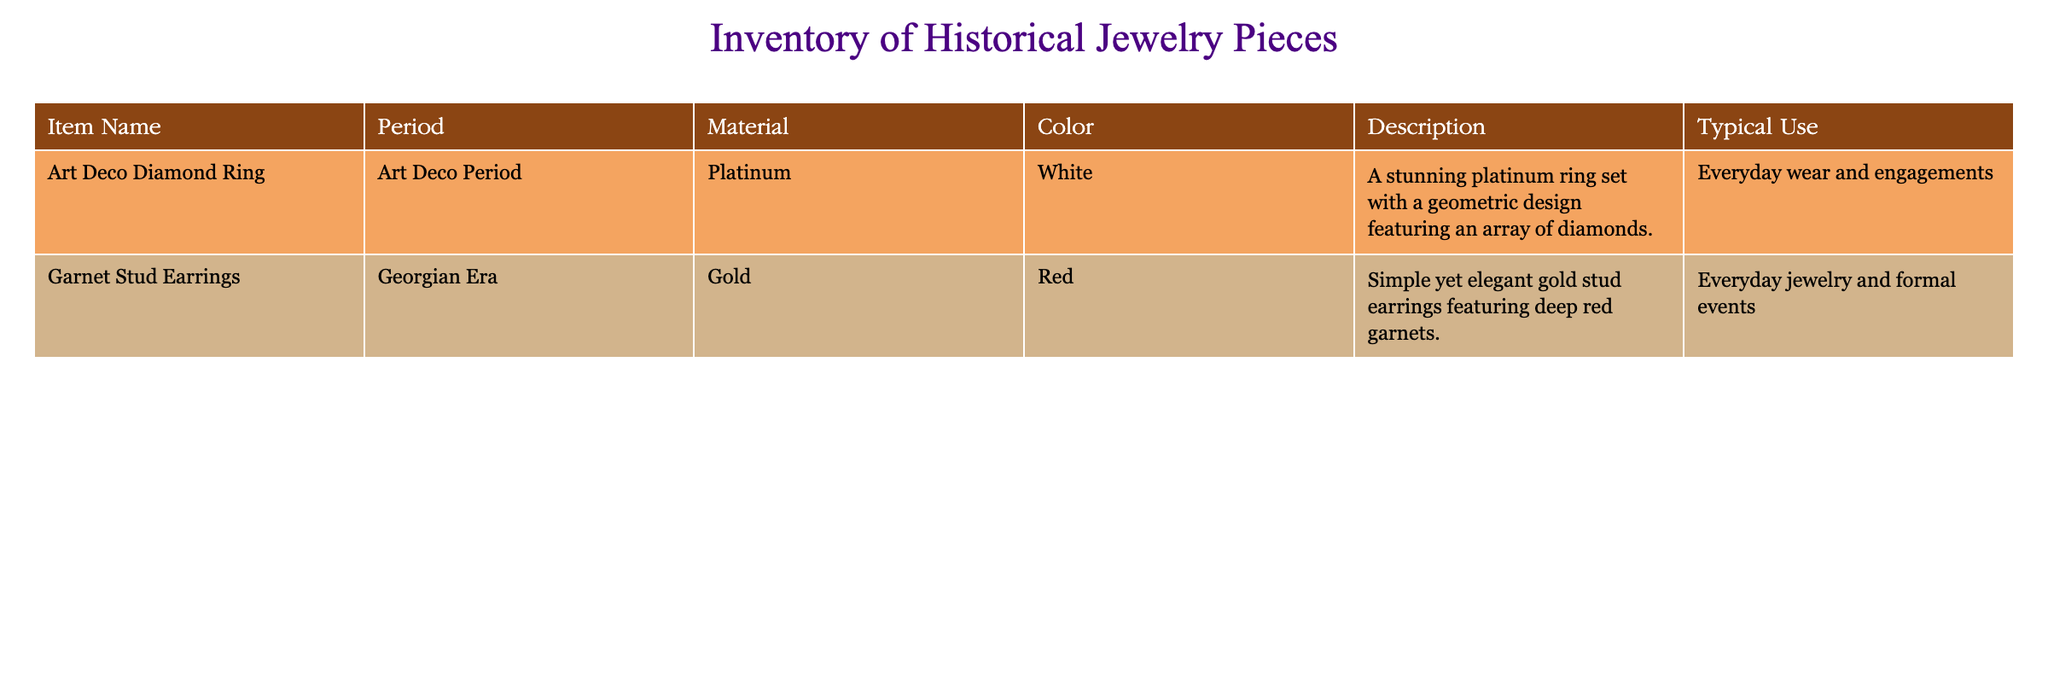What is the color of the Art Deco Diamond Ring? The color of the Art Deco Diamond Ring is listed in the table under the 'Color' column, which states it is white.
Answer: White What material is used for the Garnet Stud Earrings? According to the table, the material of the Garnet Stud Earrings is gold.
Answer: Gold What period does the Art Deco Diamond Ring belong to? The table indicates that the Art Deco Diamond Ring is from the Art Deco Period.
Answer: Art Deco Period Are both jewelry pieces made from precious metals? The Art Deco Diamond Ring is made from platinum and the Garnet Stud Earrings from gold. Both platinum and gold are considered precious metals, making the statement true.
Answer: Yes What typical use is listed for the Garnet Stud Earrings? The typical use for the Garnet Stud Earrings is noted in the table as everyday jewelry and formal events.
Answer: Everyday jewelry and formal events How many jewelry pieces are from the Georgian Era? There is only one jewelry piece listed in the table from the Georgian Era: the Garnet Stud Earrings. Therefore, the count is 1.
Answer: 1 What is the difference in color between the two jewelry pieces? The Art Deco Diamond Ring is white in color and the Garnet Stud Earrings are red. The difference is between white and red.
Answer: White and red Which jewelry piece is described as having a geometric design? The description of the Art Deco Diamond Ring mentions it features a geometric design, whereas the Garnet Stud Earrings do not have this description.
Answer: Art Deco Diamond Ring What is the common use associated with both jewelry pieces? The common use associated with both pieces is everyday wear, as the Garnet Stud Earrings are also suitable for everyday use, while the Art Deco Diamond Ring is used for everyday wear and engagements.
Answer: Everyday wear 